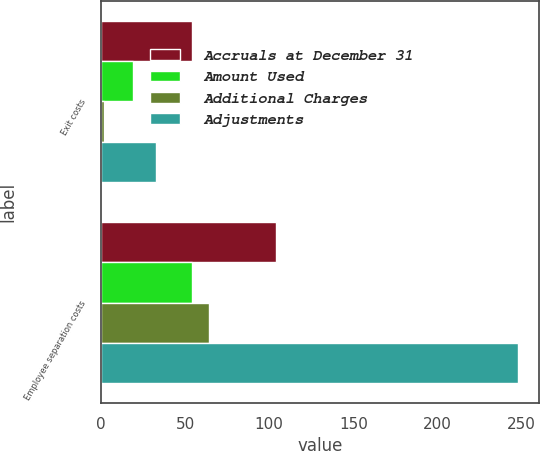<chart> <loc_0><loc_0><loc_500><loc_500><stacked_bar_chart><ecel><fcel>Exit costs<fcel>Employee separation costs<nl><fcel>Accruals at December 31<fcel>54<fcel>104<nl><fcel>Amount Used<fcel>19<fcel>54<nl><fcel>Additional Charges<fcel>2<fcel>64<nl><fcel>Adjustments<fcel>33<fcel>248<nl></chart> 